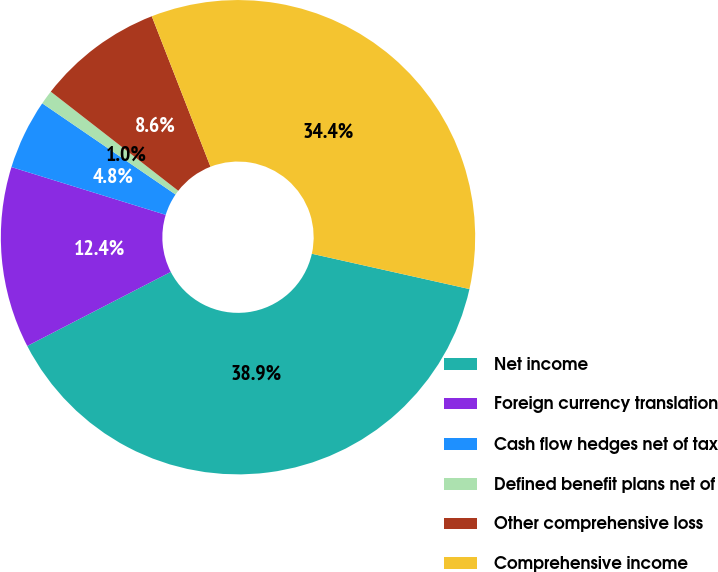<chart> <loc_0><loc_0><loc_500><loc_500><pie_chart><fcel>Net income<fcel>Foreign currency translation<fcel>Cash flow hedges net of tax<fcel>Defined benefit plans net of<fcel>Other comprehensive loss<fcel>Comprehensive income<nl><fcel>38.91%<fcel>12.36%<fcel>4.77%<fcel>0.97%<fcel>8.56%<fcel>34.43%<nl></chart> 